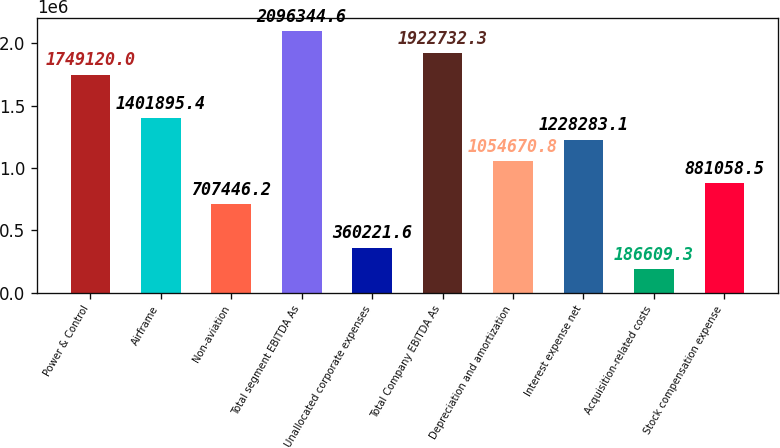Convert chart to OTSL. <chart><loc_0><loc_0><loc_500><loc_500><bar_chart><fcel>Power & Control<fcel>Airframe<fcel>Non-aviation<fcel>Total segment EBITDA As<fcel>Unallocated corporate expenses<fcel>Total Company EBITDA As<fcel>Depreciation and amortization<fcel>Interest expense net<fcel>Acquisition-related costs<fcel>Stock compensation expense<nl><fcel>1.74912e+06<fcel>1.4019e+06<fcel>707446<fcel>2.09634e+06<fcel>360222<fcel>1.92273e+06<fcel>1.05467e+06<fcel>1.22828e+06<fcel>186609<fcel>881058<nl></chart> 